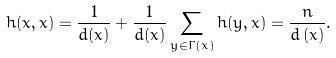Convert formula to latex. <formula><loc_0><loc_0><loc_500><loc_500>h ( x , x ) = \frac { 1 } { d ( x ) } + \frac { 1 } { d ( x ) } \sum _ { y \in \Gamma \left ( x \right ) } h ( y , x ) = \frac { n } { d \left ( x \right ) } .</formula> 